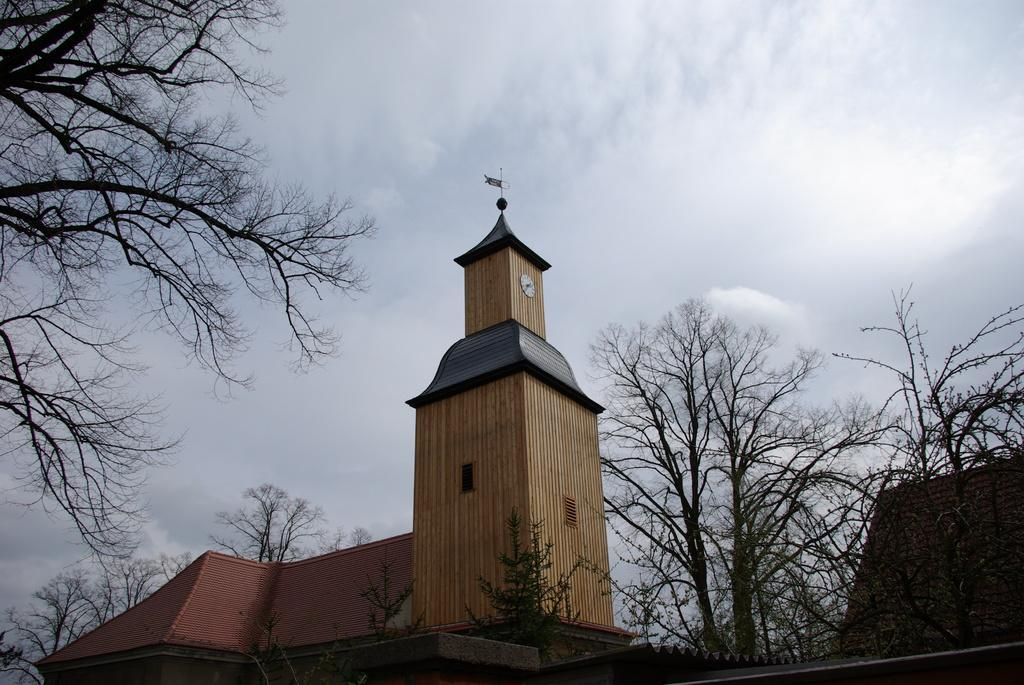What type of structure is present in the image? There is a building in the image. What colors are used on the building? The building has cream and maroon colors. What type of vegetation can be seen in the image? There are dried trees in the image. What is visible in the background of the image? The sky is visible in the background of the image. What can be observed in the sky? There are clouds in the sky. What hobbies does the friend enjoy at school? There is no reference to hobbies, friends, or school in the image. 